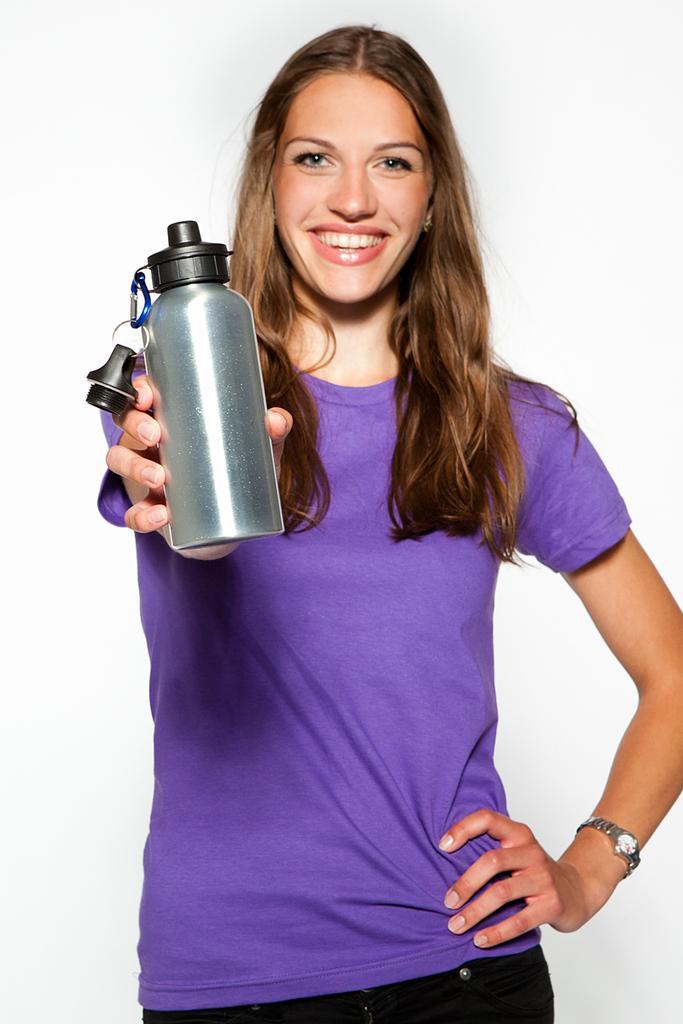Can you describe this image briefly? This picture shows a woman smiling and holding a bottle in her hand. In the background there is white color. 